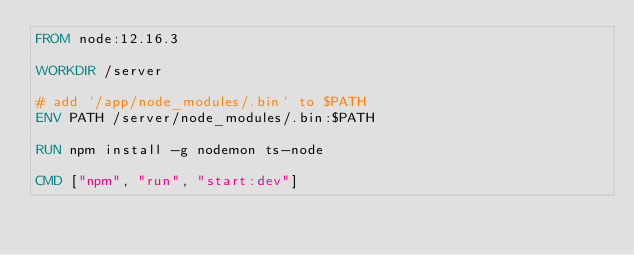Convert code to text. <code><loc_0><loc_0><loc_500><loc_500><_Dockerfile_>FROM node:12.16.3

WORKDIR /server

# add `/app/node_modules/.bin` to $PATH
ENV PATH /server/node_modules/.bin:$PATH

RUN npm install -g nodemon ts-node

CMD ["npm", "run", "start:dev"]</code> 